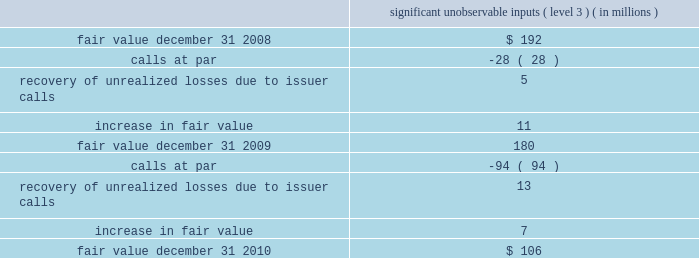Mastercard incorporated notes to consolidated financial statements 2014continued the municipal bond portfolio is comprised of tax exempt bonds and is diversified across states and sectors .
The portfolio has an average credit quality of double-a .
The short-term bond funds invest in fixed income securities , including corporate bonds , mortgage-backed securities and asset-backed securities .
The company holds investments in ars .
Interest on these securities is exempt from u.s .
Federal income tax and the interest rate on the securities typically resets every 35 days .
The securities are fully collateralized by student loans with guarantees , ranging from approximately 95% ( 95 % ) to 98% ( 98 % ) of principal and interest , by the u.s .
Government via the department of education .
Beginning on february 11 , 2008 , the auction mechanism that normally provided liquidity to the ars investments began to fail .
Since mid-february 2008 , all investment positions in the company 2019s ars investment portfolio have experienced failed auctions .
The securities for which auctions have failed have continued to pay interest in accordance with the contractual terms of such instruments and will continue to accrue interest and be auctioned at each respective reset date until the auction succeeds , the issuer redeems the securities or they mature .
During 2008 , ars were reclassified as level 3 from level 2 .
As of december 31 , 2010 , the ars market remained illiquid , but issuer call and redemption activity in the ars student loan sector has occurred periodically since the auctions began to fail .
During 2010 and 2009 , the company did not sell any ars in the auction market , but there were calls at par .
The table below includes a roll-forward of the company 2019s ars investments from january 1 , 2009 to december 31 , 2010 .
Significant unobservable inputs ( level 3 ) ( in millions ) .
The company evaluated the estimated impairment of its ars portfolio to determine if it was other-than- temporary .
The company considered several factors including , but not limited to , the following : ( 1 ) the reasons for the decline in value ( changes in interest rates , credit event , or market fluctuations ) ; ( 2 ) assessments as to whether it is more likely than not that it will hold and not be required to sell the investments for a sufficient period of time to allow for recovery of the cost basis ; ( 3 ) whether the decline is substantial ; and ( 4 ) the historical and anticipated duration of the events causing the decline in value .
The evaluation for other-than-temporary impairments is a quantitative and qualitative process , which is subject to various risks and uncertainties .
The risks and uncertainties include changes in credit quality , market liquidity , timing and amounts of issuer calls and interest rates .
As of december 31 , 2010 , the company believed that the unrealized losses on the ars were not related to credit quality but rather due to the lack of liquidity in the market .
The company believes that it is more .
What was the percent of the change in the significant unobservable inputs from 2008 to 2009? 
Rationale: the significant unobservable inputs from 2008 to 2009 changed by -6.25%
Computations: ((180 - 192) / 192)
Answer: -0.0625. 